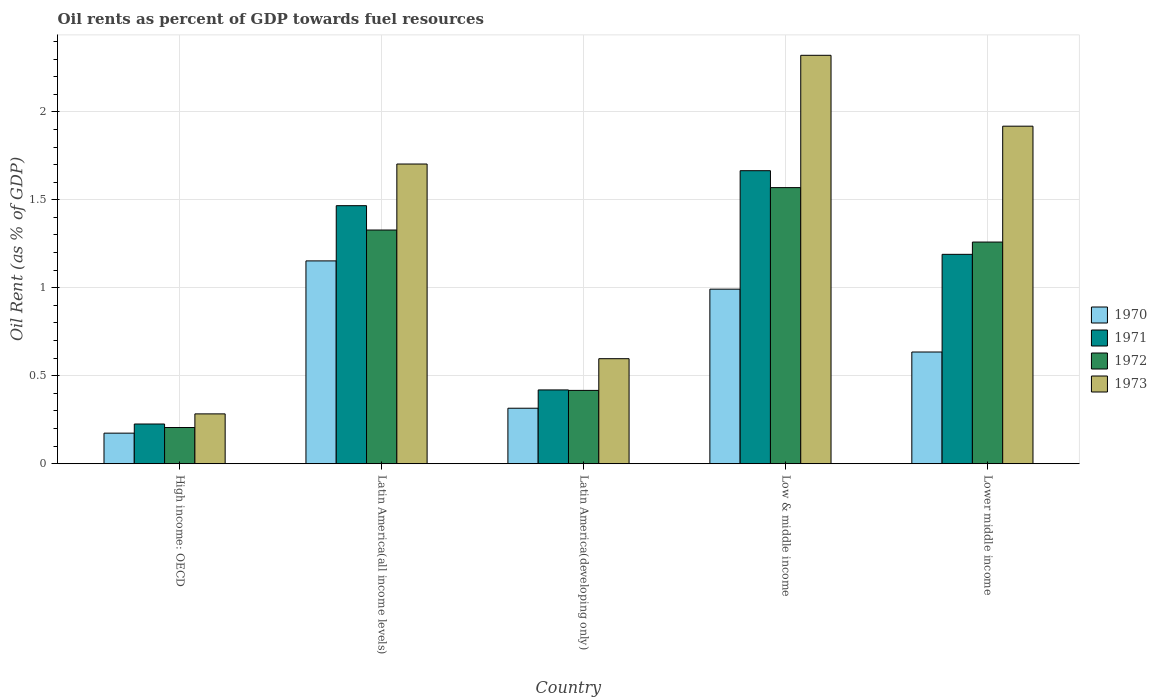Are the number of bars per tick equal to the number of legend labels?
Ensure brevity in your answer.  Yes. Are the number of bars on each tick of the X-axis equal?
Your response must be concise. Yes. How many bars are there on the 2nd tick from the left?
Ensure brevity in your answer.  4. How many bars are there on the 4th tick from the right?
Your answer should be very brief. 4. What is the label of the 2nd group of bars from the left?
Your answer should be very brief. Latin America(all income levels). What is the oil rent in 1973 in Latin America(all income levels)?
Ensure brevity in your answer.  1.7. Across all countries, what is the maximum oil rent in 1970?
Offer a terse response. 1.15. Across all countries, what is the minimum oil rent in 1970?
Your answer should be very brief. 0.17. In which country was the oil rent in 1973 maximum?
Provide a short and direct response. Low & middle income. In which country was the oil rent in 1971 minimum?
Offer a terse response. High income: OECD. What is the total oil rent in 1972 in the graph?
Provide a succinct answer. 4.78. What is the difference between the oil rent in 1973 in High income: OECD and that in Latin America(all income levels)?
Offer a very short reply. -1.42. What is the difference between the oil rent in 1970 in Lower middle income and the oil rent in 1972 in High income: OECD?
Your answer should be very brief. 0.43. What is the average oil rent in 1973 per country?
Ensure brevity in your answer.  1.36. What is the difference between the oil rent of/in 1973 and oil rent of/in 1972 in Low & middle income?
Offer a terse response. 0.75. What is the ratio of the oil rent in 1971 in Latin America(developing only) to that in Low & middle income?
Provide a succinct answer. 0.25. What is the difference between the highest and the second highest oil rent in 1970?
Make the answer very short. -0.16. What is the difference between the highest and the lowest oil rent in 1971?
Offer a very short reply. 1.44. What does the 3rd bar from the left in High income: OECD represents?
Make the answer very short. 1972. How many countries are there in the graph?
Offer a terse response. 5. What is the difference between two consecutive major ticks on the Y-axis?
Your answer should be very brief. 0.5. Are the values on the major ticks of Y-axis written in scientific E-notation?
Your answer should be compact. No. How many legend labels are there?
Give a very brief answer. 4. How are the legend labels stacked?
Keep it short and to the point. Vertical. What is the title of the graph?
Your answer should be compact. Oil rents as percent of GDP towards fuel resources. What is the label or title of the X-axis?
Give a very brief answer. Country. What is the label or title of the Y-axis?
Your answer should be compact. Oil Rent (as % of GDP). What is the Oil Rent (as % of GDP) in 1970 in High income: OECD?
Make the answer very short. 0.17. What is the Oil Rent (as % of GDP) in 1971 in High income: OECD?
Ensure brevity in your answer.  0.23. What is the Oil Rent (as % of GDP) of 1972 in High income: OECD?
Offer a very short reply. 0.21. What is the Oil Rent (as % of GDP) in 1973 in High income: OECD?
Ensure brevity in your answer.  0.28. What is the Oil Rent (as % of GDP) of 1970 in Latin America(all income levels)?
Offer a terse response. 1.15. What is the Oil Rent (as % of GDP) in 1971 in Latin America(all income levels)?
Offer a terse response. 1.47. What is the Oil Rent (as % of GDP) in 1972 in Latin America(all income levels)?
Your response must be concise. 1.33. What is the Oil Rent (as % of GDP) of 1973 in Latin America(all income levels)?
Provide a succinct answer. 1.7. What is the Oil Rent (as % of GDP) in 1970 in Latin America(developing only)?
Keep it short and to the point. 0.32. What is the Oil Rent (as % of GDP) in 1971 in Latin America(developing only)?
Offer a terse response. 0.42. What is the Oil Rent (as % of GDP) of 1972 in Latin America(developing only)?
Offer a terse response. 0.42. What is the Oil Rent (as % of GDP) in 1973 in Latin America(developing only)?
Give a very brief answer. 0.6. What is the Oil Rent (as % of GDP) in 1970 in Low & middle income?
Give a very brief answer. 0.99. What is the Oil Rent (as % of GDP) of 1971 in Low & middle income?
Provide a succinct answer. 1.67. What is the Oil Rent (as % of GDP) of 1972 in Low & middle income?
Your answer should be very brief. 1.57. What is the Oil Rent (as % of GDP) in 1973 in Low & middle income?
Ensure brevity in your answer.  2.32. What is the Oil Rent (as % of GDP) in 1970 in Lower middle income?
Your answer should be very brief. 0.63. What is the Oil Rent (as % of GDP) in 1971 in Lower middle income?
Ensure brevity in your answer.  1.19. What is the Oil Rent (as % of GDP) in 1972 in Lower middle income?
Your answer should be very brief. 1.26. What is the Oil Rent (as % of GDP) in 1973 in Lower middle income?
Your answer should be compact. 1.92. Across all countries, what is the maximum Oil Rent (as % of GDP) of 1970?
Make the answer very short. 1.15. Across all countries, what is the maximum Oil Rent (as % of GDP) of 1971?
Provide a succinct answer. 1.67. Across all countries, what is the maximum Oil Rent (as % of GDP) of 1972?
Keep it short and to the point. 1.57. Across all countries, what is the maximum Oil Rent (as % of GDP) in 1973?
Your response must be concise. 2.32. Across all countries, what is the minimum Oil Rent (as % of GDP) of 1970?
Provide a short and direct response. 0.17. Across all countries, what is the minimum Oil Rent (as % of GDP) in 1971?
Offer a very short reply. 0.23. Across all countries, what is the minimum Oil Rent (as % of GDP) in 1972?
Provide a succinct answer. 0.21. Across all countries, what is the minimum Oil Rent (as % of GDP) in 1973?
Your response must be concise. 0.28. What is the total Oil Rent (as % of GDP) of 1970 in the graph?
Your answer should be very brief. 3.27. What is the total Oil Rent (as % of GDP) in 1971 in the graph?
Your response must be concise. 4.97. What is the total Oil Rent (as % of GDP) of 1972 in the graph?
Provide a succinct answer. 4.78. What is the total Oil Rent (as % of GDP) in 1973 in the graph?
Keep it short and to the point. 6.82. What is the difference between the Oil Rent (as % of GDP) in 1970 in High income: OECD and that in Latin America(all income levels)?
Your response must be concise. -0.98. What is the difference between the Oil Rent (as % of GDP) in 1971 in High income: OECD and that in Latin America(all income levels)?
Provide a succinct answer. -1.24. What is the difference between the Oil Rent (as % of GDP) of 1972 in High income: OECD and that in Latin America(all income levels)?
Your answer should be compact. -1.12. What is the difference between the Oil Rent (as % of GDP) of 1973 in High income: OECD and that in Latin America(all income levels)?
Offer a very short reply. -1.42. What is the difference between the Oil Rent (as % of GDP) of 1970 in High income: OECD and that in Latin America(developing only)?
Your answer should be compact. -0.14. What is the difference between the Oil Rent (as % of GDP) of 1971 in High income: OECD and that in Latin America(developing only)?
Provide a succinct answer. -0.19. What is the difference between the Oil Rent (as % of GDP) of 1972 in High income: OECD and that in Latin America(developing only)?
Your response must be concise. -0.21. What is the difference between the Oil Rent (as % of GDP) in 1973 in High income: OECD and that in Latin America(developing only)?
Give a very brief answer. -0.31. What is the difference between the Oil Rent (as % of GDP) in 1970 in High income: OECD and that in Low & middle income?
Your response must be concise. -0.82. What is the difference between the Oil Rent (as % of GDP) of 1971 in High income: OECD and that in Low & middle income?
Ensure brevity in your answer.  -1.44. What is the difference between the Oil Rent (as % of GDP) in 1972 in High income: OECD and that in Low & middle income?
Your answer should be very brief. -1.36. What is the difference between the Oil Rent (as % of GDP) of 1973 in High income: OECD and that in Low & middle income?
Give a very brief answer. -2.04. What is the difference between the Oil Rent (as % of GDP) in 1970 in High income: OECD and that in Lower middle income?
Your answer should be very brief. -0.46. What is the difference between the Oil Rent (as % of GDP) in 1971 in High income: OECD and that in Lower middle income?
Provide a short and direct response. -0.96. What is the difference between the Oil Rent (as % of GDP) of 1972 in High income: OECD and that in Lower middle income?
Your response must be concise. -1.05. What is the difference between the Oil Rent (as % of GDP) in 1973 in High income: OECD and that in Lower middle income?
Offer a very short reply. -1.64. What is the difference between the Oil Rent (as % of GDP) in 1970 in Latin America(all income levels) and that in Latin America(developing only)?
Your response must be concise. 0.84. What is the difference between the Oil Rent (as % of GDP) in 1971 in Latin America(all income levels) and that in Latin America(developing only)?
Provide a short and direct response. 1.05. What is the difference between the Oil Rent (as % of GDP) of 1972 in Latin America(all income levels) and that in Latin America(developing only)?
Your answer should be compact. 0.91. What is the difference between the Oil Rent (as % of GDP) in 1973 in Latin America(all income levels) and that in Latin America(developing only)?
Your answer should be very brief. 1.11. What is the difference between the Oil Rent (as % of GDP) of 1970 in Latin America(all income levels) and that in Low & middle income?
Provide a succinct answer. 0.16. What is the difference between the Oil Rent (as % of GDP) in 1971 in Latin America(all income levels) and that in Low & middle income?
Provide a short and direct response. -0.2. What is the difference between the Oil Rent (as % of GDP) of 1972 in Latin America(all income levels) and that in Low & middle income?
Your response must be concise. -0.24. What is the difference between the Oil Rent (as % of GDP) in 1973 in Latin America(all income levels) and that in Low & middle income?
Provide a short and direct response. -0.62. What is the difference between the Oil Rent (as % of GDP) of 1970 in Latin America(all income levels) and that in Lower middle income?
Make the answer very short. 0.52. What is the difference between the Oil Rent (as % of GDP) of 1971 in Latin America(all income levels) and that in Lower middle income?
Make the answer very short. 0.28. What is the difference between the Oil Rent (as % of GDP) of 1972 in Latin America(all income levels) and that in Lower middle income?
Ensure brevity in your answer.  0.07. What is the difference between the Oil Rent (as % of GDP) in 1973 in Latin America(all income levels) and that in Lower middle income?
Your answer should be compact. -0.21. What is the difference between the Oil Rent (as % of GDP) in 1970 in Latin America(developing only) and that in Low & middle income?
Provide a short and direct response. -0.68. What is the difference between the Oil Rent (as % of GDP) in 1971 in Latin America(developing only) and that in Low & middle income?
Your answer should be compact. -1.25. What is the difference between the Oil Rent (as % of GDP) of 1972 in Latin America(developing only) and that in Low & middle income?
Provide a succinct answer. -1.15. What is the difference between the Oil Rent (as % of GDP) of 1973 in Latin America(developing only) and that in Low & middle income?
Ensure brevity in your answer.  -1.72. What is the difference between the Oil Rent (as % of GDP) of 1970 in Latin America(developing only) and that in Lower middle income?
Ensure brevity in your answer.  -0.32. What is the difference between the Oil Rent (as % of GDP) of 1971 in Latin America(developing only) and that in Lower middle income?
Keep it short and to the point. -0.77. What is the difference between the Oil Rent (as % of GDP) in 1972 in Latin America(developing only) and that in Lower middle income?
Keep it short and to the point. -0.84. What is the difference between the Oil Rent (as % of GDP) in 1973 in Latin America(developing only) and that in Lower middle income?
Your answer should be compact. -1.32. What is the difference between the Oil Rent (as % of GDP) in 1970 in Low & middle income and that in Lower middle income?
Your answer should be very brief. 0.36. What is the difference between the Oil Rent (as % of GDP) of 1971 in Low & middle income and that in Lower middle income?
Give a very brief answer. 0.48. What is the difference between the Oil Rent (as % of GDP) in 1972 in Low & middle income and that in Lower middle income?
Provide a succinct answer. 0.31. What is the difference between the Oil Rent (as % of GDP) in 1973 in Low & middle income and that in Lower middle income?
Your answer should be very brief. 0.4. What is the difference between the Oil Rent (as % of GDP) of 1970 in High income: OECD and the Oil Rent (as % of GDP) of 1971 in Latin America(all income levels)?
Your answer should be compact. -1.29. What is the difference between the Oil Rent (as % of GDP) of 1970 in High income: OECD and the Oil Rent (as % of GDP) of 1972 in Latin America(all income levels)?
Provide a succinct answer. -1.15. What is the difference between the Oil Rent (as % of GDP) of 1970 in High income: OECD and the Oil Rent (as % of GDP) of 1973 in Latin America(all income levels)?
Keep it short and to the point. -1.53. What is the difference between the Oil Rent (as % of GDP) in 1971 in High income: OECD and the Oil Rent (as % of GDP) in 1972 in Latin America(all income levels)?
Keep it short and to the point. -1.1. What is the difference between the Oil Rent (as % of GDP) in 1971 in High income: OECD and the Oil Rent (as % of GDP) in 1973 in Latin America(all income levels)?
Your response must be concise. -1.48. What is the difference between the Oil Rent (as % of GDP) of 1972 in High income: OECD and the Oil Rent (as % of GDP) of 1973 in Latin America(all income levels)?
Your answer should be compact. -1.5. What is the difference between the Oil Rent (as % of GDP) in 1970 in High income: OECD and the Oil Rent (as % of GDP) in 1971 in Latin America(developing only)?
Provide a short and direct response. -0.25. What is the difference between the Oil Rent (as % of GDP) of 1970 in High income: OECD and the Oil Rent (as % of GDP) of 1972 in Latin America(developing only)?
Offer a very short reply. -0.24. What is the difference between the Oil Rent (as % of GDP) of 1970 in High income: OECD and the Oil Rent (as % of GDP) of 1973 in Latin America(developing only)?
Your answer should be very brief. -0.42. What is the difference between the Oil Rent (as % of GDP) of 1971 in High income: OECD and the Oil Rent (as % of GDP) of 1972 in Latin America(developing only)?
Your response must be concise. -0.19. What is the difference between the Oil Rent (as % of GDP) of 1971 in High income: OECD and the Oil Rent (as % of GDP) of 1973 in Latin America(developing only)?
Your answer should be very brief. -0.37. What is the difference between the Oil Rent (as % of GDP) in 1972 in High income: OECD and the Oil Rent (as % of GDP) in 1973 in Latin America(developing only)?
Your response must be concise. -0.39. What is the difference between the Oil Rent (as % of GDP) of 1970 in High income: OECD and the Oil Rent (as % of GDP) of 1971 in Low & middle income?
Provide a short and direct response. -1.49. What is the difference between the Oil Rent (as % of GDP) in 1970 in High income: OECD and the Oil Rent (as % of GDP) in 1972 in Low & middle income?
Provide a succinct answer. -1.4. What is the difference between the Oil Rent (as % of GDP) in 1970 in High income: OECD and the Oil Rent (as % of GDP) in 1973 in Low & middle income?
Provide a succinct answer. -2.15. What is the difference between the Oil Rent (as % of GDP) of 1971 in High income: OECD and the Oil Rent (as % of GDP) of 1972 in Low & middle income?
Offer a very short reply. -1.34. What is the difference between the Oil Rent (as % of GDP) in 1971 in High income: OECD and the Oil Rent (as % of GDP) in 1973 in Low & middle income?
Offer a terse response. -2.1. What is the difference between the Oil Rent (as % of GDP) of 1972 in High income: OECD and the Oil Rent (as % of GDP) of 1973 in Low & middle income?
Keep it short and to the point. -2.12. What is the difference between the Oil Rent (as % of GDP) of 1970 in High income: OECD and the Oil Rent (as % of GDP) of 1971 in Lower middle income?
Make the answer very short. -1.02. What is the difference between the Oil Rent (as % of GDP) of 1970 in High income: OECD and the Oil Rent (as % of GDP) of 1972 in Lower middle income?
Provide a short and direct response. -1.09. What is the difference between the Oil Rent (as % of GDP) in 1970 in High income: OECD and the Oil Rent (as % of GDP) in 1973 in Lower middle income?
Provide a succinct answer. -1.74. What is the difference between the Oil Rent (as % of GDP) of 1971 in High income: OECD and the Oil Rent (as % of GDP) of 1972 in Lower middle income?
Keep it short and to the point. -1.03. What is the difference between the Oil Rent (as % of GDP) of 1971 in High income: OECD and the Oil Rent (as % of GDP) of 1973 in Lower middle income?
Provide a short and direct response. -1.69. What is the difference between the Oil Rent (as % of GDP) of 1972 in High income: OECD and the Oil Rent (as % of GDP) of 1973 in Lower middle income?
Offer a terse response. -1.71. What is the difference between the Oil Rent (as % of GDP) in 1970 in Latin America(all income levels) and the Oil Rent (as % of GDP) in 1971 in Latin America(developing only)?
Your answer should be very brief. 0.73. What is the difference between the Oil Rent (as % of GDP) in 1970 in Latin America(all income levels) and the Oil Rent (as % of GDP) in 1972 in Latin America(developing only)?
Keep it short and to the point. 0.74. What is the difference between the Oil Rent (as % of GDP) of 1970 in Latin America(all income levels) and the Oil Rent (as % of GDP) of 1973 in Latin America(developing only)?
Provide a succinct answer. 0.56. What is the difference between the Oil Rent (as % of GDP) of 1971 in Latin America(all income levels) and the Oil Rent (as % of GDP) of 1972 in Latin America(developing only)?
Your answer should be very brief. 1.05. What is the difference between the Oil Rent (as % of GDP) in 1971 in Latin America(all income levels) and the Oil Rent (as % of GDP) in 1973 in Latin America(developing only)?
Your answer should be very brief. 0.87. What is the difference between the Oil Rent (as % of GDP) of 1972 in Latin America(all income levels) and the Oil Rent (as % of GDP) of 1973 in Latin America(developing only)?
Your answer should be very brief. 0.73. What is the difference between the Oil Rent (as % of GDP) of 1970 in Latin America(all income levels) and the Oil Rent (as % of GDP) of 1971 in Low & middle income?
Your answer should be very brief. -0.51. What is the difference between the Oil Rent (as % of GDP) of 1970 in Latin America(all income levels) and the Oil Rent (as % of GDP) of 1972 in Low & middle income?
Offer a very short reply. -0.42. What is the difference between the Oil Rent (as % of GDP) of 1970 in Latin America(all income levels) and the Oil Rent (as % of GDP) of 1973 in Low & middle income?
Provide a short and direct response. -1.17. What is the difference between the Oil Rent (as % of GDP) of 1971 in Latin America(all income levels) and the Oil Rent (as % of GDP) of 1972 in Low & middle income?
Your response must be concise. -0.1. What is the difference between the Oil Rent (as % of GDP) in 1971 in Latin America(all income levels) and the Oil Rent (as % of GDP) in 1973 in Low & middle income?
Provide a short and direct response. -0.85. What is the difference between the Oil Rent (as % of GDP) in 1972 in Latin America(all income levels) and the Oil Rent (as % of GDP) in 1973 in Low & middle income?
Your answer should be very brief. -0.99. What is the difference between the Oil Rent (as % of GDP) of 1970 in Latin America(all income levels) and the Oil Rent (as % of GDP) of 1971 in Lower middle income?
Your response must be concise. -0.04. What is the difference between the Oil Rent (as % of GDP) in 1970 in Latin America(all income levels) and the Oil Rent (as % of GDP) in 1972 in Lower middle income?
Keep it short and to the point. -0.11. What is the difference between the Oil Rent (as % of GDP) of 1970 in Latin America(all income levels) and the Oil Rent (as % of GDP) of 1973 in Lower middle income?
Keep it short and to the point. -0.77. What is the difference between the Oil Rent (as % of GDP) in 1971 in Latin America(all income levels) and the Oil Rent (as % of GDP) in 1972 in Lower middle income?
Your answer should be very brief. 0.21. What is the difference between the Oil Rent (as % of GDP) in 1971 in Latin America(all income levels) and the Oil Rent (as % of GDP) in 1973 in Lower middle income?
Provide a succinct answer. -0.45. What is the difference between the Oil Rent (as % of GDP) of 1972 in Latin America(all income levels) and the Oil Rent (as % of GDP) of 1973 in Lower middle income?
Keep it short and to the point. -0.59. What is the difference between the Oil Rent (as % of GDP) of 1970 in Latin America(developing only) and the Oil Rent (as % of GDP) of 1971 in Low & middle income?
Your answer should be very brief. -1.35. What is the difference between the Oil Rent (as % of GDP) in 1970 in Latin America(developing only) and the Oil Rent (as % of GDP) in 1972 in Low & middle income?
Offer a very short reply. -1.25. What is the difference between the Oil Rent (as % of GDP) of 1970 in Latin America(developing only) and the Oil Rent (as % of GDP) of 1973 in Low & middle income?
Provide a succinct answer. -2.01. What is the difference between the Oil Rent (as % of GDP) in 1971 in Latin America(developing only) and the Oil Rent (as % of GDP) in 1972 in Low & middle income?
Provide a succinct answer. -1.15. What is the difference between the Oil Rent (as % of GDP) of 1971 in Latin America(developing only) and the Oil Rent (as % of GDP) of 1973 in Low & middle income?
Provide a succinct answer. -1.9. What is the difference between the Oil Rent (as % of GDP) of 1972 in Latin America(developing only) and the Oil Rent (as % of GDP) of 1973 in Low & middle income?
Make the answer very short. -1.9. What is the difference between the Oil Rent (as % of GDP) of 1970 in Latin America(developing only) and the Oil Rent (as % of GDP) of 1971 in Lower middle income?
Provide a succinct answer. -0.87. What is the difference between the Oil Rent (as % of GDP) in 1970 in Latin America(developing only) and the Oil Rent (as % of GDP) in 1972 in Lower middle income?
Your response must be concise. -0.94. What is the difference between the Oil Rent (as % of GDP) in 1970 in Latin America(developing only) and the Oil Rent (as % of GDP) in 1973 in Lower middle income?
Offer a terse response. -1.6. What is the difference between the Oil Rent (as % of GDP) of 1971 in Latin America(developing only) and the Oil Rent (as % of GDP) of 1972 in Lower middle income?
Ensure brevity in your answer.  -0.84. What is the difference between the Oil Rent (as % of GDP) of 1971 in Latin America(developing only) and the Oil Rent (as % of GDP) of 1973 in Lower middle income?
Your answer should be compact. -1.5. What is the difference between the Oil Rent (as % of GDP) in 1972 in Latin America(developing only) and the Oil Rent (as % of GDP) in 1973 in Lower middle income?
Offer a terse response. -1.5. What is the difference between the Oil Rent (as % of GDP) of 1970 in Low & middle income and the Oil Rent (as % of GDP) of 1971 in Lower middle income?
Your answer should be very brief. -0.2. What is the difference between the Oil Rent (as % of GDP) of 1970 in Low & middle income and the Oil Rent (as % of GDP) of 1972 in Lower middle income?
Provide a short and direct response. -0.27. What is the difference between the Oil Rent (as % of GDP) in 1970 in Low & middle income and the Oil Rent (as % of GDP) in 1973 in Lower middle income?
Provide a short and direct response. -0.93. What is the difference between the Oil Rent (as % of GDP) of 1971 in Low & middle income and the Oil Rent (as % of GDP) of 1972 in Lower middle income?
Your answer should be compact. 0.41. What is the difference between the Oil Rent (as % of GDP) in 1971 in Low & middle income and the Oil Rent (as % of GDP) in 1973 in Lower middle income?
Provide a short and direct response. -0.25. What is the difference between the Oil Rent (as % of GDP) of 1972 in Low & middle income and the Oil Rent (as % of GDP) of 1973 in Lower middle income?
Offer a very short reply. -0.35. What is the average Oil Rent (as % of GDP) of 1970 per country?
Offer a very short reply. 0.65. What is the average Oil Rent (as % of GDP) of 1971 per country?
Your response must be concise. 0.99. What is the average Oil Rent (as % of GDP) of 1972 per country?
Offer a very short reply. 0.96. What is the average Oil Rent (as % of GDP) in 1973 per country?
Offer a terse response. 1.36. What is the difference between the Oil Rent (as % of GDP) of 1970 and Oil Rent (as % of GDP) of 1971 in High income: OECD?
Provide a short and direct response. -0.05. What is the difference between the Oil Rent (as % of GDP) of 1970 and Oil Rent (as % of GDP) of 1972 in High income: OECD?
Provide a short and direct response. -0.03. What is the difference between the Oil Rent (as % of GDP) in 1970 and Oil Rent (as % of GDP) in 1973 in High income: OECD?
Your response must be concise. -0.11. What is the difference between the Oil Rent (as % of GDP) in 1971 and Oil Rent (as % of GDP) in 1972 in High income: OECD?
Offer a very short reply. 0.02. What is the difference between the Oil Rent (as % of GDP) in 1971 and Oil Rent (as % of GDP) in 1973 in High income: OECD?
Ensure brevity in your answer.  -0.06. What is the difference between the Oil Rent (as % of GDP) in 1972 and Oil Rent (as % of GDP) in 1973 in High income: OECD?
Keep it short and to the point. -0.08. What is the difference between the Oil Rent (as % of GDP) in 1970 and Oil Rent (as % of GDP) in 1971 in Latin America(all income levels)?
Your answer should be compact. -0.31. What is the difference between the Oil Rent (as % of GDP) of 1970 and Oil Rent (as % of GDP) of 1972 in Latin America(all income levels)?
Ensure brevity in your answer.  -0.18. What is the difference between the Oil Rent (as % of GDP) in 1970 and Oil Rent (as % of GDP) in 1973 in Latin America(all income levels)?
Ensure brevity in your answer.  -0.55. What is the difference between the Oil Rent (as % of GDP) in 1971 and Oil Rent (as % of GDP) in 1972 in Latin America(all income levels)?
Offer a terse response. 0.14. What is the difference between the Oil Rent (as % of GDP) in 1971 and Oil Rent (as % of GDP) in 1973 in Latin America(all income levels)?
Keep it short and to the point. -0.24. What is the difference between the Oil Rent (as % of GDP) in 1972 and Oil Rent (as % of GDP) in 1973 in Latin America(all income levels)?
Your response must be concise. -0.38. What is the difference between the Oil Rent (as % of GDP) of 1970 and Oil Rent (as % of GDP) of 1971 in Latin America(developing only)?
Your answer should be compact. -0.1. What is the difference between the Oil Rent (as % of GDP) in 1970 and Oil Rent (as % of GDP) in 1972 in Latin America(developing only)?
Your answer should be very brief. -0.1. What is the difference between the Oil Rent (as % of GDP) of 1970 and Oil Rent (as % of GDP) of 1973 in Latin America(developing only)?
Keep it short and to the point. -0.28. What is the difference between the Oil Rent (as % of GDP) in 1971 and Oil Rent (as % of GDP) in 1972 in Latin America(developing only)?
Offer a very short reply. 0. What is the difference between the Oil Rent (as % of GDP) in 1971 and Oil Rent (as % of GDP) in 1973 in Latin America(developing only)?
Make the answer very short. -0.18. What is the difference between the Oil Rent (as % of GDP) in 1972 and Oil Rent (as % of GDP) in 1973 in Latin America(developing only)?
Provide a short and direct response. -0.18. What is the difference between the Oil Rent (as % of GDP) of 1970 and Oil Rent (as % of GDP) of 1971 in Low & middle income?
Give a very brief answer. -0.67. What is the difference between the Oil Rent (as % of GDP) of 1970 and Oil Rent (as % of GDP) of 1972 in Low & middle income?
Offer a terse response. -0.58. What is the difference between the Oil Rent (as % of GDP) in 1970 and Oil Rent (as % of GDP) in 1973 in Low & middle income?
Give a very brief answer. -1.33. What is the difference between the Oil Rent (as % of GDP) of 1971 and Oil Rent (as % of GDP) of 1972 in Low & middle income?
Give a very brief answer. 0.1. What is the difference between the Oil Rent (as % of GDP) in 1971 and Oil Rent (as % of GDP) in 1973 in Low & middle income?
Make the answer very short. -0.66. What is the difference between the Oil Rent (as % of GDP) in 1972 and Oil Rent (as % of GDP) in 1973 in Low & middle income?
Offer a terse response. -0.75. What is the difference between the Oil Rent (as % of GDP) in 1970 and Oil Rent (as % of GDP) in 1971 in Lower middle income?
Give a very brief answer. -0.56. What is the difference between the Oil Rent (as % of GDP) of 1970 and Oil Rent (as % of GDP) of 1972 in Lower middle income?
Ensure brevity in your answer.  -0.62. What is the difference between the Oil Rent (as % of GDP) in 1970 and Oil Rent (as % of GDP) in 1973 in Lower middle income?
Make the answer very short. -1.28. What is the difference between the Oil Rent (as % of GDP) in 1971 and Oil Rent (as % of GDP) in 1972 in Lower middle income?
Provide a short and direct response. -0.07. What is the difference between the Oil Rent (as % of GDP) in 1971 and Oil Rent (as % of GDP) in 1973 in Lower middle income?
Ensure brevity in your answer.  -0.73. What is the difference between the Oil Rent (as % of GDP) in 1972 and Oil Rent (as % of GDP) in 1973 in Lower middle income?
Offer a very short reply. -0.66. What is the ratio of the Oil Rent (as % of GDP) of 1970 in High income: OECD to that in Latin America(all income levels)?
Make the answer very short. 0.15. What is the ratio of the Oil Rent (as % of GDP) in 1971 in High income: OECD to that in Latin America(all income levels)?
Your answer should be compact. 0.15. What is the ratio of the Oil Rent (as % of GDP) in 1972 in High income: OECD to that in Latin America(all income levels)?
Keep it short and to the point. 0.15. What is the ratio of the Oil Rent (as % of GDP) of 1973 in High income: OECD to that in Latin America(all income levels)?
Provide a succinct answer. 0.17. What is the ratio of the Oil Rent (as % of GDP) in 1970 in High income: OECD to that in Latin America(developing only)?
Ensure brevity in your answer.  0.55. What is the ratio of the Oil Rent (as % of GDP) of 1971 in High income: OECD to that in Latin America(developing only)?
Keep it short and to the point. 0.54. What is the ratio of the Oil Rent (as % of GDP) of 1972 in High income: OECD to that in Latin America(developing only)?
Give a very brief answer. 0.49. What is the ratio of the Oil Rent (as % of GDP) of 1973 in High income: OECD to that in Latin America(developing only)?
Make the answer very short. 0.47. What is the ratio of the Oil Rent (as % of GDP) in 1970 in High income: OECD to that in Low & middle income?
Provide a short and direct response. 0.18. What is the ratio of the Oil Rent (as % of GDP) of 1971 in High income: OECD to that in Low & middle income?
Keep it short and to the point. 0.14. What is the ratio of the Oil Rent (as % of GDP) in 1972 in High income: OECD to that in Low & middle income?
Your answer should be very brief. 0.13. What is the ratio of the Oil Rent (as % of GDP) in 1973 in High income: OECD to that in Low & middle income?
Provide a succinct answer. 0.12. What is the ratio of the Oil Rent (as % of GDP) of 1970 in High income: OECD to that in Lower middle income?
Your answer should be compact. 0.27. What is the ratio of the Oil Rent (as % of GDP) of 1971 in High income: OECD to that in Lower middle income?
Provide a short and direct response. 0.19. What is the ratio of the Oil Rent (as % of GDP) in 1972 in High income: OECD to that in Lower middle income?
Offer a terse response. 0.16. What is the ratio of the Oil Rent (as % of GDP) in 1973 in High income: OECD to that in Lower middle income?
Give a very brief answer. 0.15. What is the ratio of the Oil Rent (as % of GDP) of 1970 in Latin America(all income levels) to that in Latin America(developing only)?
Offer a very short reply. 3.65. What is the ratio of the Oil Rent (as % of GDP) in 1971 in Latin America(all income levels) to that in Latin America(developing only)?
Your answer should be very brief. 3.5. What is the ratio of the Oil Rent (as % of GDP) in 1972 in Latin America(all income levels) to that in Latin America(developing only)?
Give a very brief answer. 3.19. What is the ratio of the Oil Rent (as % of GDP) in 1973 in Latin America(all income levels) to that in Latin America(developing only)?
Offer a very short reply. 2.85. What is the ratio of the Oil Rent (as % of GDP) in 1970 in Latin America(all income levels) to that in Low & middle income?
Keep it short and to the point. 1.16. What is the ratio of the Oil Rent (as % of GDP) of 1971 in Latin America(all income levels) to that in Low & middle income?
Your answer should be compact. 0.88. What is the ratio of the Oil Rent (as % of GDP) in 1972 in Latin America(all income levels) to that in Low & middle income?
Keep it short and to the point. 0.85. What is the ratio of the Oil Rent (as % of GDP) in 1973 in Latin America(all income levels) to that in Low & middle income?
Keep it short and to the point. 0.73. What is the ratio of the Oil Rent (as % of GDP) of 1970 in Latin America(all income levels) to that in Lower middle income?
Provide a succinct answer. 1.82. What is the ratio of the Oil Rent (as % of GDP) of 1971 in Latin America(all income levels) to that in Lower middle income?
Make the answer very short. 1.23. What is the ratio of the Oil Rent (as % of GDP) in 1972 in Latin America(all income levels) to that in Lower middle income?
Your response must be concise. 1.05. What is the ratio of the Oil Rent (as % of GDP) of 1973 in Latin America(all income levels) to that in Lower middle income?
Your response must be concise. 0.89. What is the ratio of the Oil Rent (as % of GDP) of 1970 in Latin America(developing only) to that in Low & middle income?
Your answer should be very brief. 0.32. What is the ratio of the Oil Rent (as % of GDP) of 1971 in Latin America(developing only) to that in Low & middle income?
Your response must be concise. 0.25. What is the ratio of the Oil Rent (as % of GDP) in 1972 in Latin America(developing only) to that in Low & middle income?
Your answer should be compact. 0.27. What is the ratio of the Oil Rent (as % of GDP) in 1973 in Latin America(developing only) to that in Low & middle income?
Your response must be concise. 0.26. What is the ratio of the Oil Rent (as % of GDP) in 1970 in Latin America(developing only) to that in Lower middle income?
Your response must be concise. 0.5. What is the ratio of the Oil Rent (as % of GDP) in 1971 in Latin America(developing only) to that in Lower middle income?
Your response must be concise. 0.35. What is the ratio of the Oil Rent (as % of GDP) of 1972 in Latin America(developing only) to that in Lower middle income?
Your answer should be compact. 0.33. What is the ratio of the Oil Rent (as % of GDP) of 1973 in Latin America(developing only) to that in Lower middle income?
Your answer should be very brief. 0.31. What is the ratio of the Oil Rent (as % of GDP) of 1970 in Low & middle income to that in Lower middle income?
Ensure brevity in your answer.  1.56. What is the ratio of the Oil Rent (as % of GDP) of 1971 in Low & middle income to that in Lower middle income?
Offer a terse response. 1.4. What is the ratio of the Oil Rent (as % of GDP) of 1972 in Low & middle income to that in Lower middle income?
Offer a terse response. 1.25. What is the ratio of the Oil Rent (as % of GDP) of 1973 in Low & middle income to that in Lower middle income?
Your response must be concise. 1.21. What is the difference between the highest and the second highest Oil Rent (as % of GDP) of 1970?
Your answer should be compact. 0.16. What is the difference between the highest and the second highest Oil Rent (as % of GDP) in 1971?
Give a very brief answer. 0.2. What is the difference between the highest and the second highest Oil Rent (as % of GDP) of 1972?
Provide a succinct answer. 0.24. What is the difference between the highest and the second highest Oil Rent (as % of GDP) of 1973?
Your response must be concise. 0.4. What is the difference between the highest and the lowest Oil Rent (as % of GDP) of 1970?
Provide a succinct answer. 0.98. What is the difference between the highest and the lowest Oil Rent (as % of GDP) of 1971?
Your response must be concise. 1.44. What is the difference between the highest and the lowest Oil Rent (as % of GDP) in 1972?
Ensure brevity in your answer.  1.36. What is the difference between the highest and the lowest Oil Rent (as % of GDP) in 1973?
Make the answer very short. 2.04. 